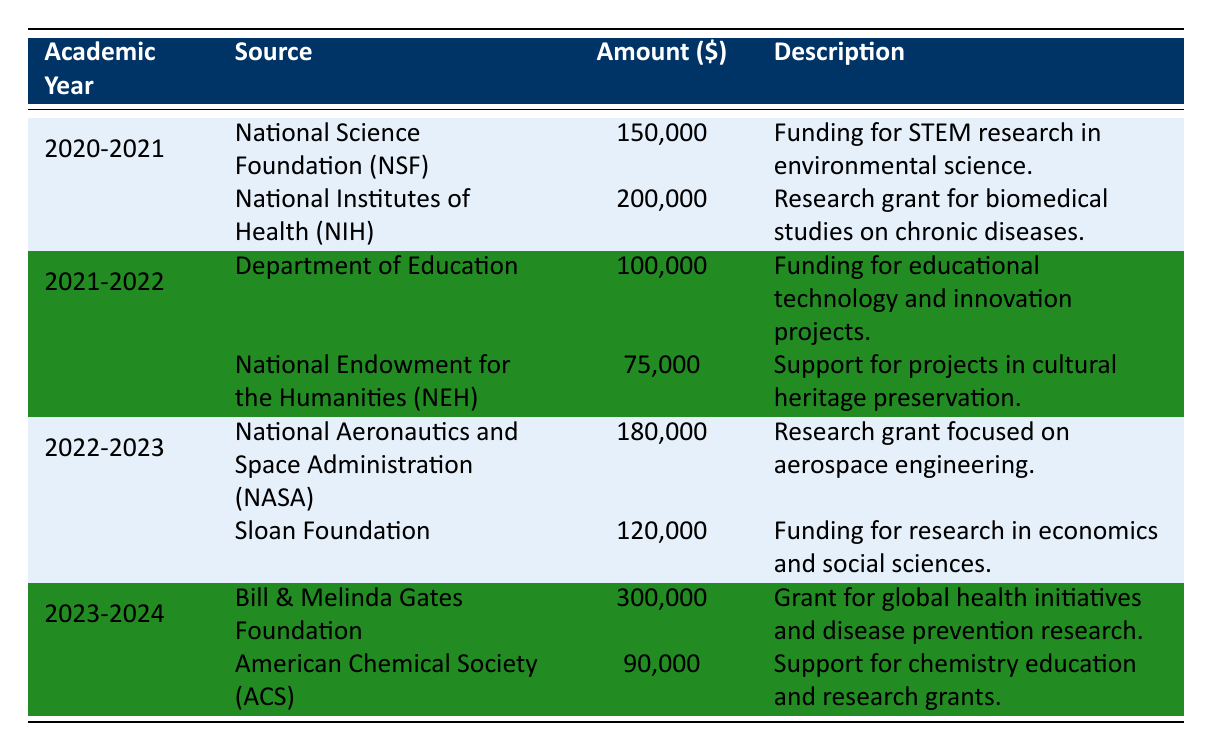What was the total amount of funding received from the National Institutes of Health (NIH) in the 2020-2021 academic year? The table shows that the amount received from NIH in 2020-2021 was 200,000.
Answer: 200,000 How many different funding sources were listed for the academic year 2021-2022? The table indicates two funding sources for 2021-2022: Department of Education and National Endowment for the Humanities (NEH).
Answer: 2 What is the average amount received from funding sources in the academic year 2022-2023? The amounts received in 2022-2023 are 180,000 (NASA) and 120,000 (Sloan Foundation). The sum is 180,000 + 120,000 = 300,000, and there are 2 sources; thus, the average is 300,000 / 2 = 150,000.
Answer: 150,000 Did the funding from the Bill & Melinda Gates Foundation exceed 250,000 in the 2023-2024 academic year? The table shows that the amount received from the Bill & Melinda Gates Foundation is 300,000, which is greater than 250,000.
Answer: Yes What was the total amount received across all funding sources in the academic year 2020-2021? The funding amounts for 2020-2021 are 150,000 (NSF) and 200,000 (NIH); summing these gives 150,000 + 200,000 = 350,000.
Answer: 350,000 Which academic year received the highest single amount of funding from a source, and what was that amount? In the 2023-2024 academic year, the Bill & Melinda Gates Foundation provided 300,000, which is the highest single funding amount listed in the table.
Answer: 2023-2024, 300,000 What was the total amount received from all sources across the three academic years combined? Summing all amounts: 150,000 + 200,000 + 100,000 + 75,000 + 180,000 + 120,000 + 300,000 + 90,000 gives 1,015,000.
Answer: 1,015,000 Was there any funding source that provided less than 100,000 in the academic year 2021-2022? The table shows that the National Endowment for the Humanities (NEH) provided 75,000, which is less than 100,000.
Answer: Yes What is the difference in total funding received between the academic years 2022-2023 and 2021-2022? For 2022-2023, the total is 180,000 (NASA) + 120,000 (Sloan) = 300,000. For 2021-2022, the total is 100,000 (Education) + 75,000 (NEH) = 175,000. The difference is 300,000 - 175,000 = 125,000.
Answer: 125,000 